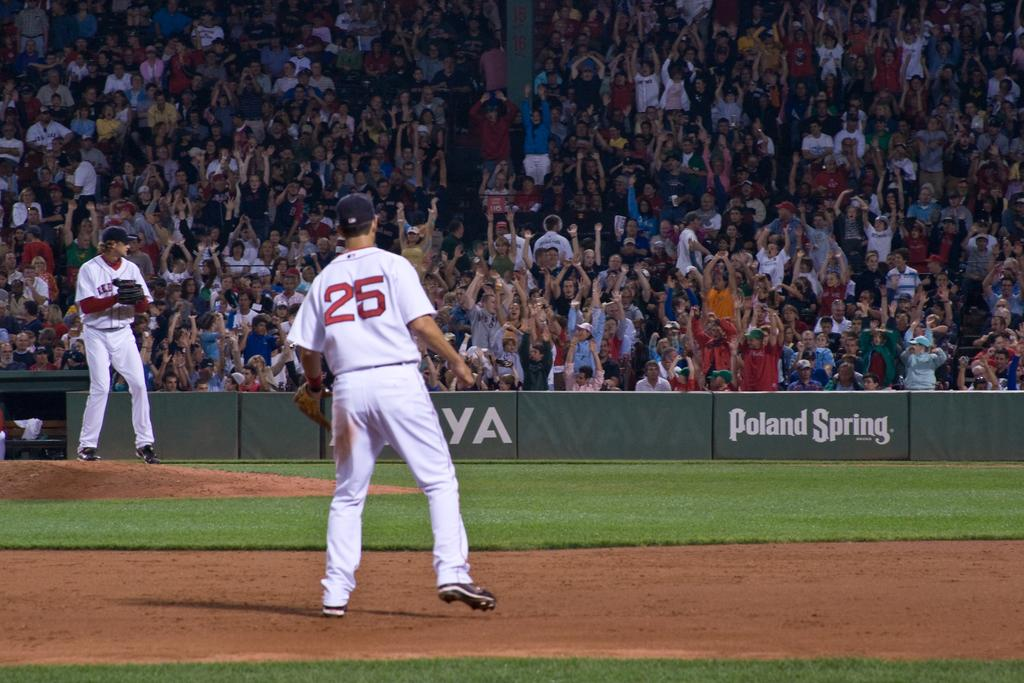<image>
Render a clear and concise summary of the photo. Poland Spring is a sponsor for this sports game. 